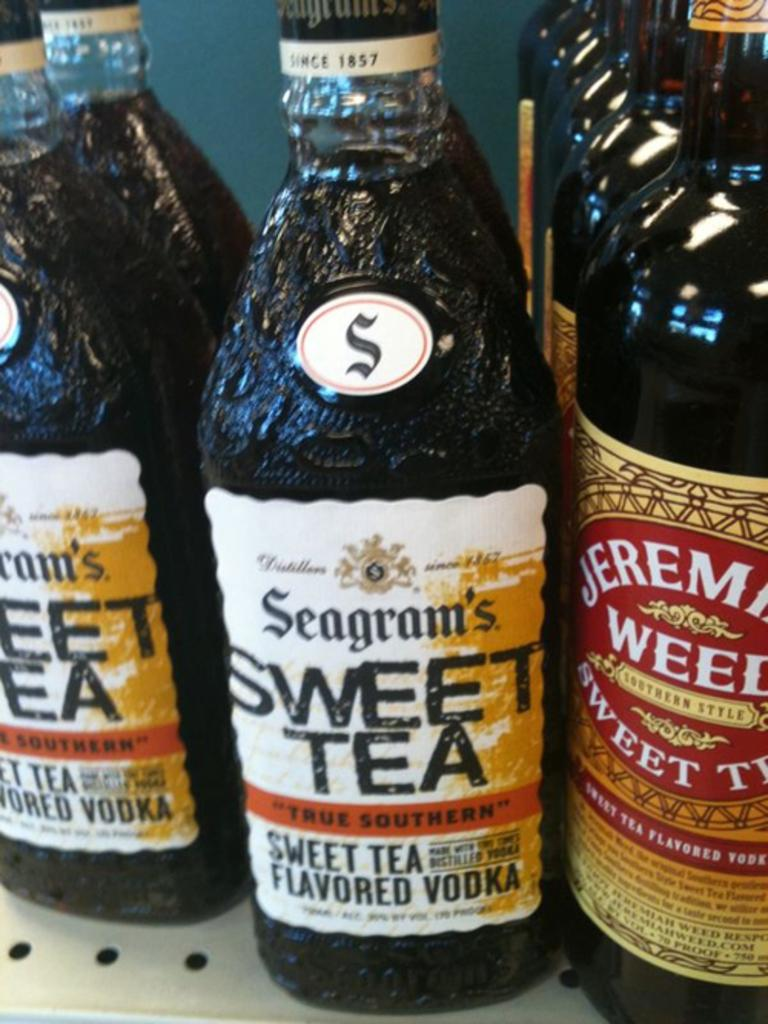<image>
Give a short and clear explanation of the subsequent image. Bottles of Seagram's Sweet Tea next to a bottle of Jeremiah Weed Sweet Tea. 